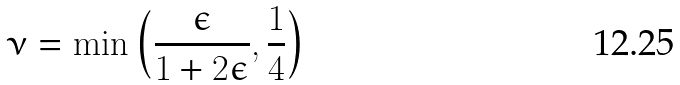Convert formula to latex. <formula><loc_0><loc_0><loc_500><loc_500>\nu = \min \left ( \frac { \epsilon } { 1 + 2 \epsilon } , \frac { 1 } { 4 } \right )</formula> 